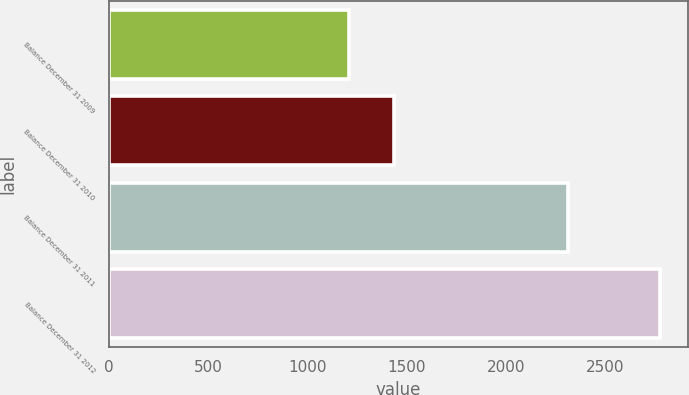<chart> <loc_0><loc_0><loc_500><loc_500><bar_chart><fcel>Balance December 31 2009<fcel>Balance December 31 2010<fcel>Balance December 31 2011<fcel>Balance December 31 2012<nl><fcel>1207<fcel>1436<fcel>2312<fcel>2775<nl></chart> 